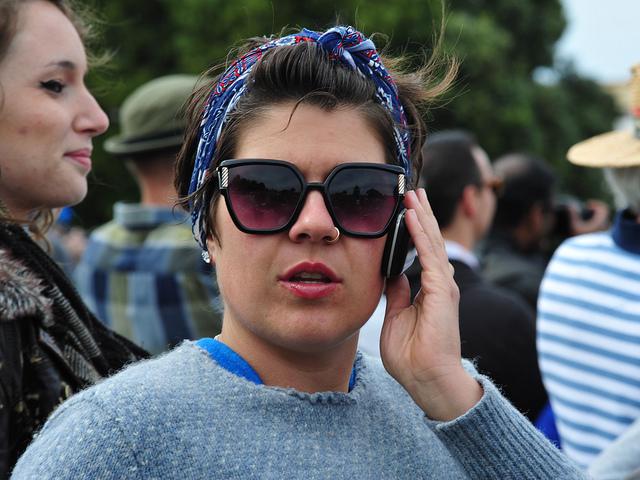Who is giving the side eye?
Write a very short answer. Woman. Who is in  glasses?
Concise answer only. Woman. What is on the woman's face?
Be succinct. Sunglasses. 